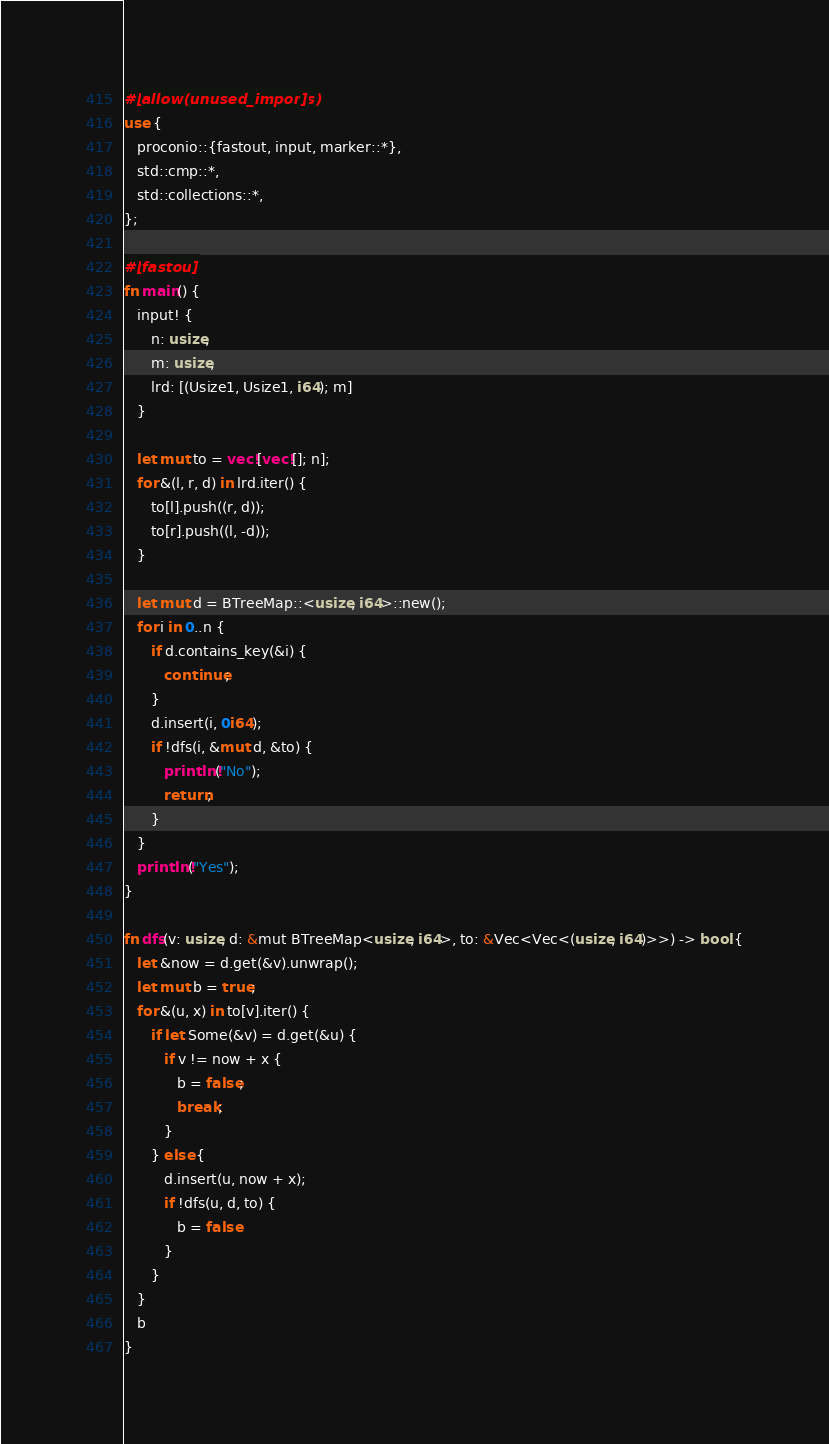Convert code to text. <code><loc_0><loc_0><loc_500><loc_500><_Rust_>#[allow(unused_imports)]
use {
   proconio::{fastout, input, marker::*},
   std::cmp::*,
   std::collections::*,
};

#[fastout]
fn main() {
   input! {
      n: usize,
      m: usize,
      lrd: [(Usize1, Usize1, i64); m]
   }

   let mut to = vec![vec![]; n];
   for &(l, r, d) in lrd.iter() {
      to[l].push((r, d));
      to[r].push((l, -d));
   }

   let mut d = BTreeMap::<usize, i64>::new();
   for i in 0..n {
      if d.contains_key(&i) {
         continue;
      }
      d.insert(i, 0i64);
      if !dfs(i, &mut d, &to) {
         println!("No");
         return;
      }
   }
   println!("Yes");
}

fn dfs(v: usize, d: &mut BTreeMap<usize, i64>, to: &Vec<Vec<(usize, i64)>>) -> bool {
   let &now = d.get(&v).unwrap();
   let mut b = true;
   for &(u, x) in to[v].iter() {
      if let Some(&v) = d.get(&u) {
         if v != now + x {
            b = false;
            break;
         }
      } else {
         d.insert(u, now + x);
         if !dfs(u, d, to) {
            b = false
         }
      }
   }
   b
}
</code> 